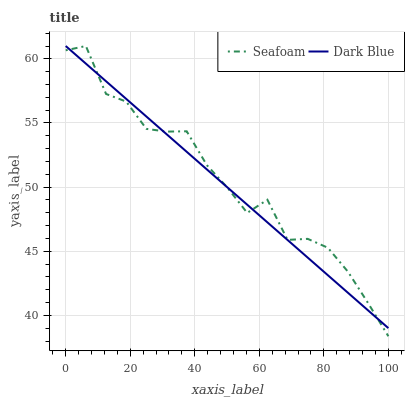Does Dark Blue have the minimum area under the curve?
Answer yes or no. Yes. Does Seafoam have the maximum area under the curve?
Answer yes or no. Yes. Does Seafoam have the minimum area under the curve?
Answer yes or no. No. Is Dark Blue the smoothest?
Answer yes or no. Yes. Is Seafoam the roughest?
Answer yes or no. Yes. Is Seafoam the smoothest?
Answer yes or no. No. Does Seafoam have the lowest value?
Answer yes or no. Yes. Does Seafoam have the highest value?
Answer yes or no. Yes. Does Seafoam intersect Dark Blue?
Answer yes or no. Yes. Is Seafoam less than Dark Blue?
Answer yes or no. No. Is Seafoam greater than Dark Blue?
Answer yes or no. No. 